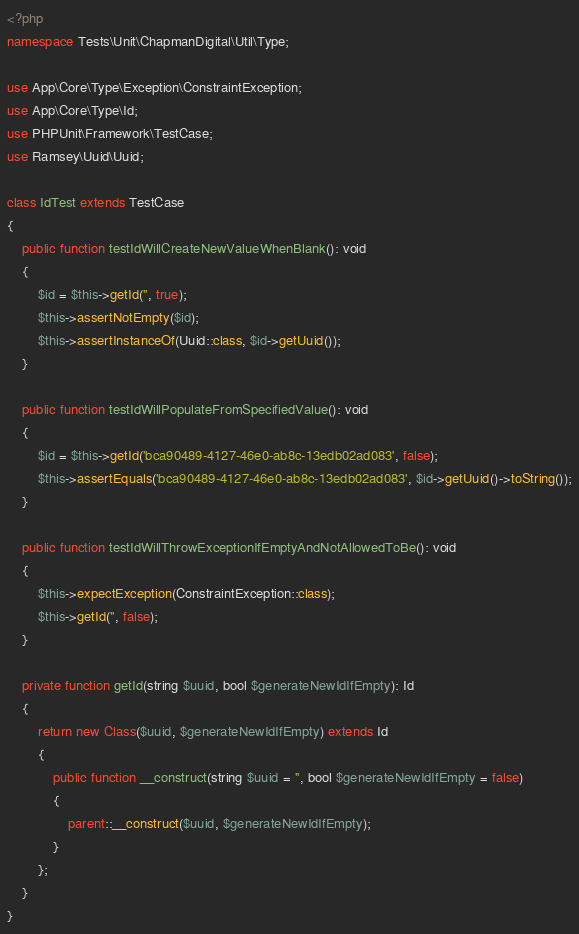Convert code to text. <code><loc_0><loc_0><loc_500><loc_500><_PHP_><?php
namespace Tests\Unit\ChapmanDigital\Util\Type;

use App\Core\Type\Exception\ConstraintException;
use App\Core\Type\Id;
use PHPUnit\Framework\TestCase;
use Ramsey\Uuid\Uuid;

class IdTest extends TestCase
{
    public function testIdWillCreateNewValueWhenBlank(): void
    {
        $id = $this->getId('', true);
        $this->assertNotEmpty($id);
        $this->assertInstanceOf(Uuid::class, $id->getUuid());
    }

    public function testIdWillPopulateFromSpecifiedValue(): void
    {
        $id = $this->getId('bca90489-4127-46e0-ab8c-13edb02ad083', false);
        $this->assertEquals('bca90489-4127-46e0-ab8c-13edb02ad083', $id->getUuid()->toString());
    }

    public function testIdWillThrowExceptionIfEmptyAndNotAllowedToBe(): void
    {
        $this->expectException(ConstraintException::class);
        $this->getId('', false);
    }

    private function getId(string $uuid, bool $generateNewIdIfEmpty): Id
    {
        return new Class($uuid, $generateNewIdIfEmpty) extends Id
        {
            public function __construct(string $uuid = '', bool $generateNewIdIfEmpty = false)
            {
                parent::__construct($uuid, $generateNewIdIfEmpty);
            }
        };
    }
}</code> 